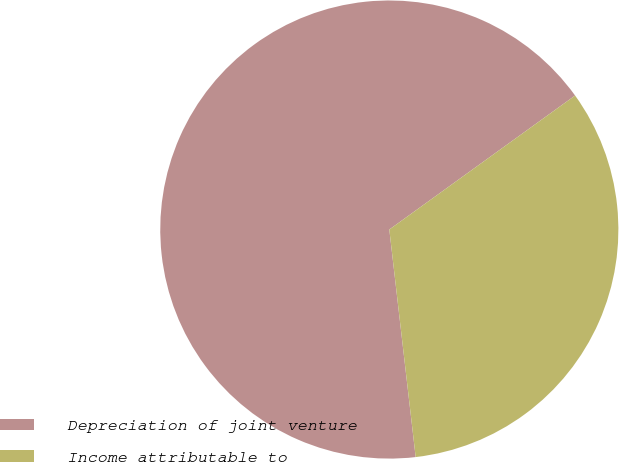Convert chart. <chart><loc_0><loc_0><loc_500><loc_500><pie_chart><fcel>Depreciation of joint venture<fcel>Income attributable to<nl><fcel>66.89%<fcel>33.11%<nl></chart> 